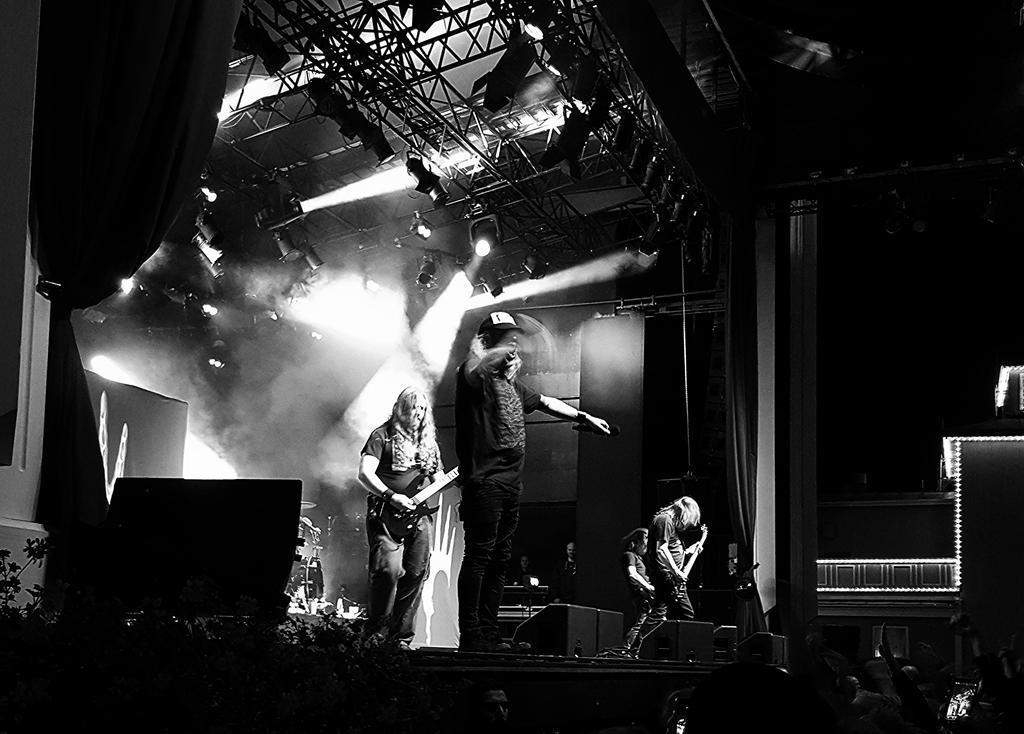In one or two sentences, can you explain what this image depicts? In this picture we can see a four people performing on a stage. They are singing on a microphone and playing a guitar. This is a roof with lighting arrangement. Here we can see a few people who are on the right side. 